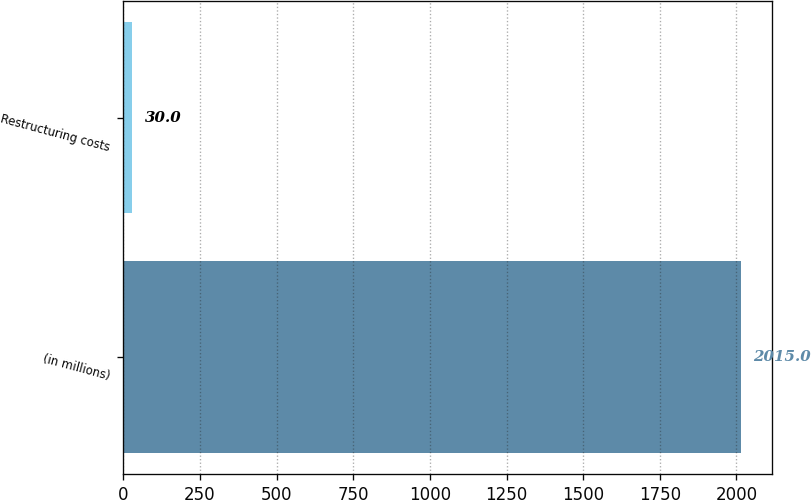Convert chart to OTSL. <chart><loc_0><loc_0><loc_500><loc_500><bar_chart><fcel>(in millions)<fcel>Restructuring costs<nl><fcel>2015<fcel>30<nl></chart> 